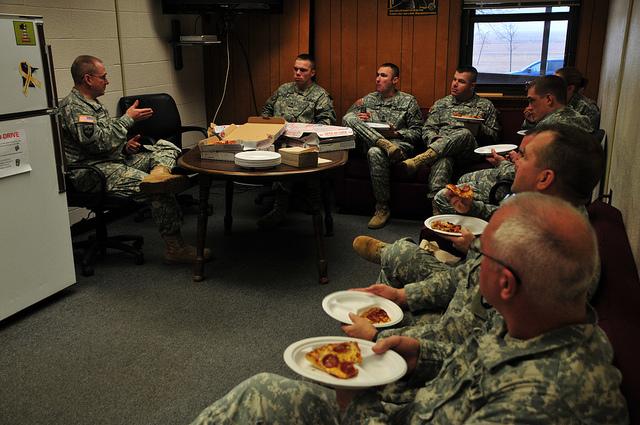How many children are in the photo?
Quick response, please. 0. What uniform are the men wearing?
Concise answer only. Army. How many women in the room?
Write a very short answer. 0. What are the men holding?
Be succinct. Plates. What are the people drinking with their meal?
Short answer required. Nothing. What food dish are the soldiers eating?
Write a very short answer. Pizza. 